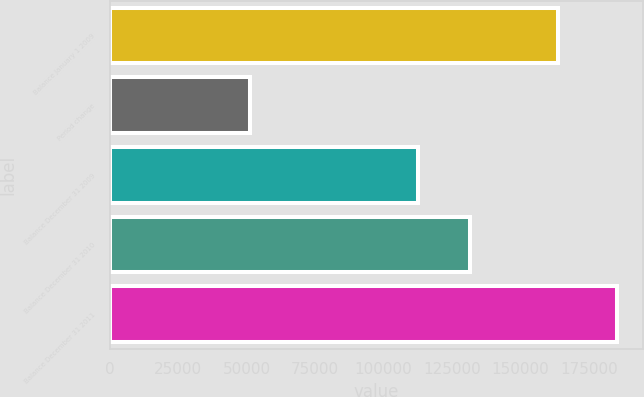<chart> <loc_0><loc_0><loc_500><loc_500><bar_chart><fcel>Balance January 1 2009<fcel>Period change<fcel>Balance December 31 2009<fcel>Balance December 31 2010<fcel>Balance December 31 2011<nl><fcel>163575<fcel>51107<fcel>112468<fcel>131489<fcel>185364<nl></chart> 